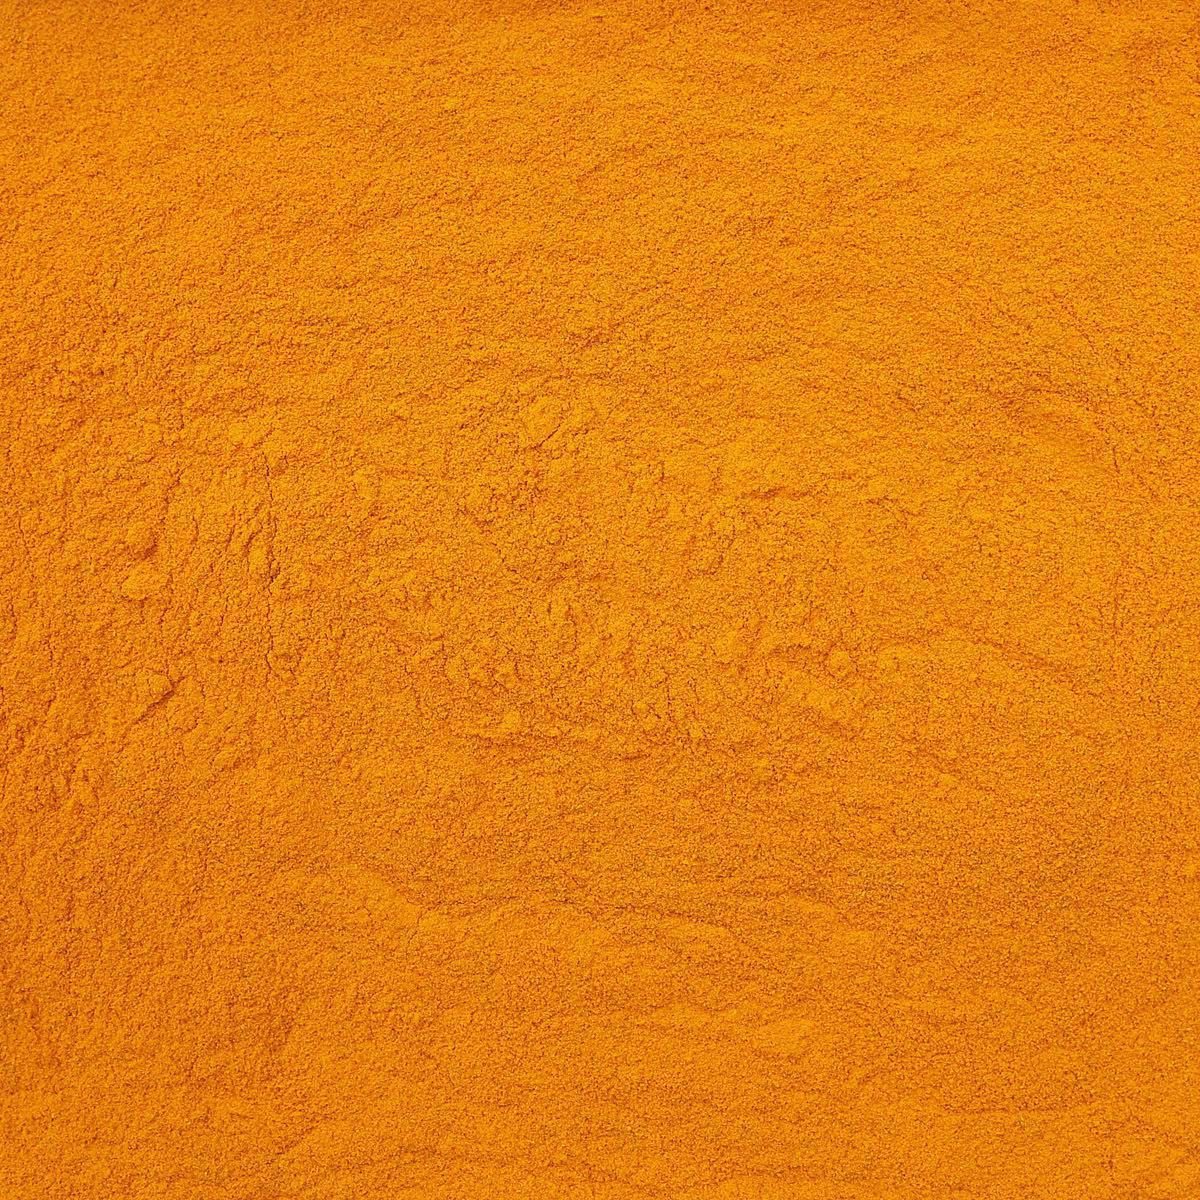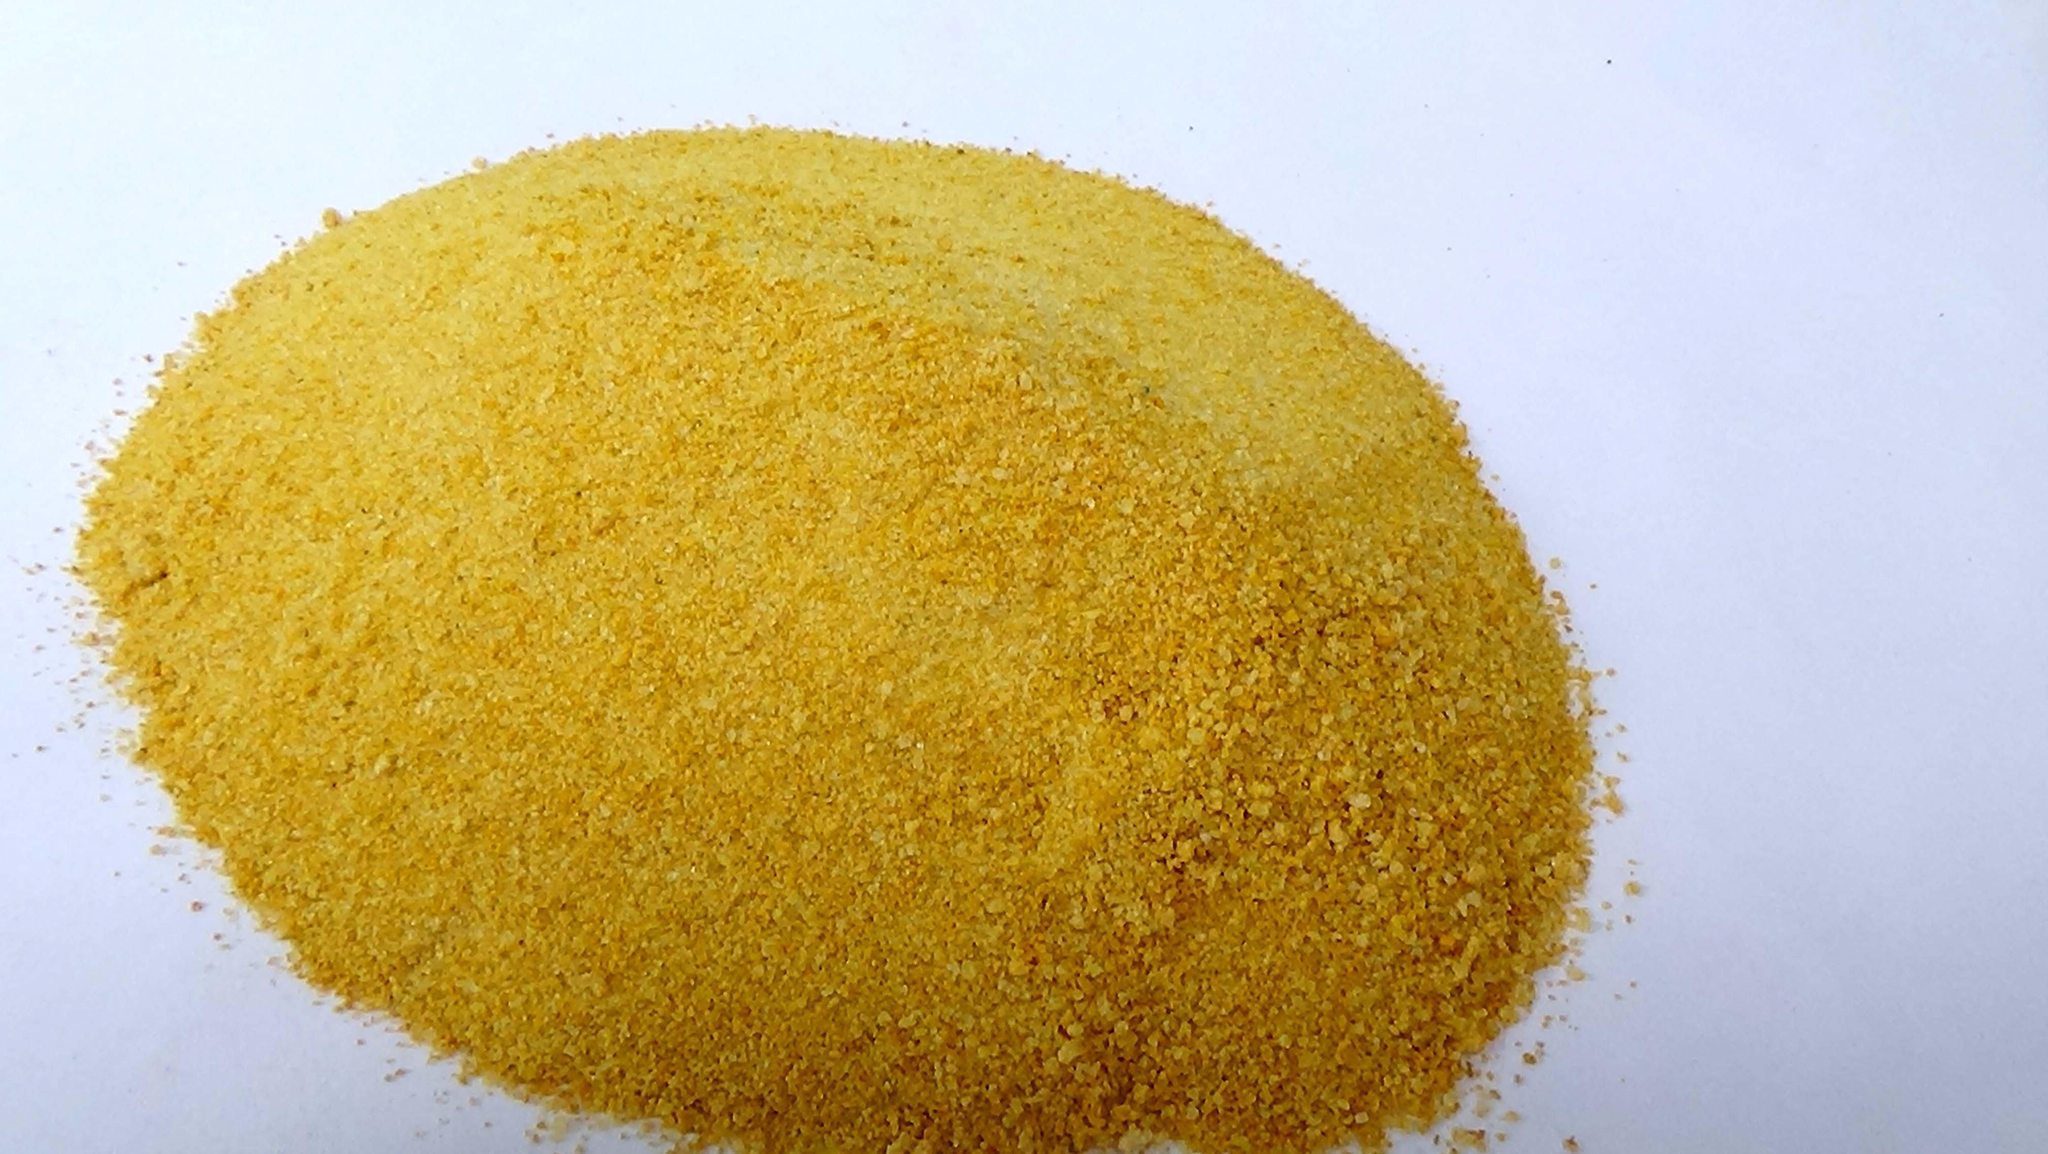The first image is the image on the left, the second image is the image on the right. Analyze the images presented: Is the assertion "One or more of the photos depict yellow-orange powder arranged in a mound." valid? Answer yes or no. Yes. The first image is the image on the left, the second image is the image on the right. Assess this claim about the two images: "An image shows a mostly round pile of golden-yellow powder.". Correct or not? Answer yes or no. Yes. 